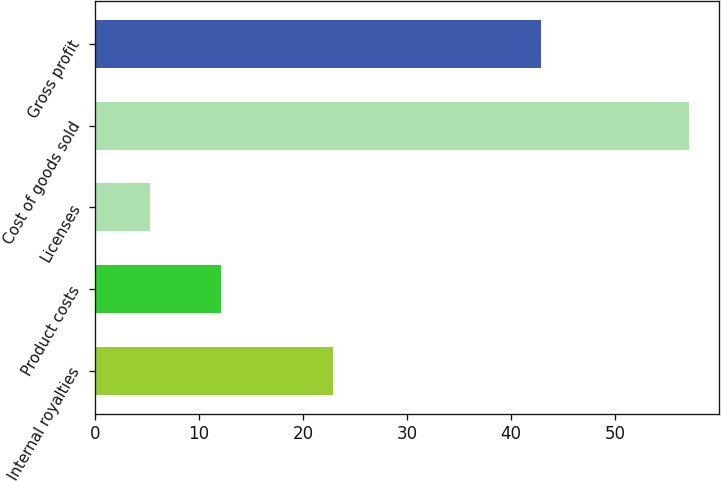<chart> <loc_0><loc_0><loc_500><loc_500><bar_chart><fcel>Internal royalties<fcel>Product costs<fcel>Licenses<fcel>Cost of goods sold<fcel>Gross profit<nl><fcel>22.9<fcel>12.1<fcel>5.3<fcel>57.1<fcel>42.9<nl></chart> 